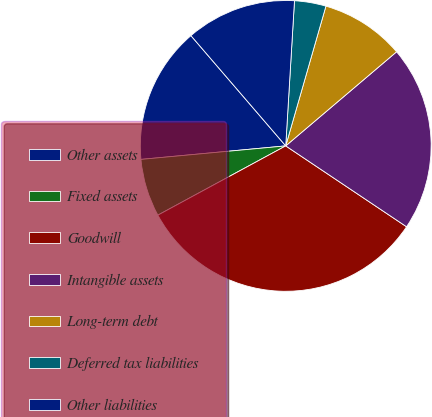<chart> <loc_0><loc_0><loc_500><loc_500><pie_chart><fcel>Other assets<fcel>Fixed assets<fcel>Goodwill<fcel>Intangible assets<fcel>Long-term debt<fcel>Deferred tax liabilities<fcel>Other liabilities<nl><fcel>15.18%<fcel>6.42%<fcel>32.71%<fcel>20.59%<fcel>9.34%<fcel>3.5%<fcel>12.26%<nl></chart> 